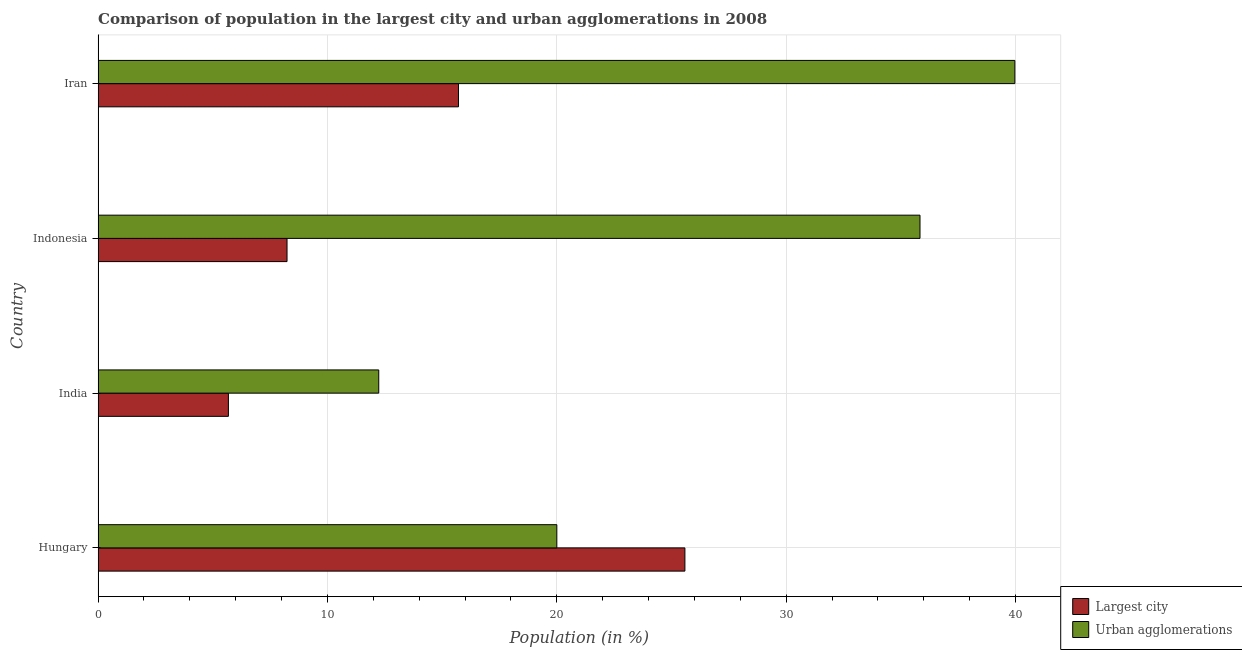How many different coloured bars are there?
Provide a succinct answer. 2. How many groups of bars are there?
Provide a succinct answer. 4. Are the number of bars on each tick of the Y-axis equal?
Give a very brief answer. Yes. How many bars are there on the 2nd tick from the top?
Provide a succinct answer. 2. How many bars are there on the 3rd tick from the bottom?
Make the answer very short. 2. What is the population in the largest city in Indonesia?
Offer a terse response. 8.24. Across all countries, what is the maximum population in the largest city?
Keep it short and to the point. 25.58. Across all countries, what is the minimum population in urban agglomerations?
Offer a very short reply. 12.24. In which country was the population in the largest city maximum?
Your response must be concise. Hungary. In which country was the population in urban agglomerations minimum?
Keep it short and to the point. India. What is the total population in urban agglomerations in the graph?
Make the answer very short. 108.04. What is the difference between the population in the largest city in India and that in Iran?
Your response must be concise. -10.03. What is the difference between the population in urban agglomerations in Hungary and the population in the largest city in Indonesia?
Provide a succinct answer. 11.76. What is the average population in the largest city per country?
Make the answer very short. 13.8. What is the difference between the population in urban agglomerations and population in the largest city in India?
Your answer should be very brief. 6.55. In how many countries, is the population in urban agglomerations greater than 26 %?
Ensure brevity in your answer.  2. What is the ratio of the population in urban agglomerations in Indonesia to that in Iran?
Keep it short and to the point. 0.9. Is the difference between the population in urban agglomerations in India and Indonesia greater than the difference between the population in the largest city in India and Indonesia?
Your answer should be compact. No. What is the difference between the highest and the second highest population in urban agglomerations?
Offer a very short reply. 4.14. What is the difference between the highest and the lowest population in urban agglomerations?
Provide a short and direct response. 27.73. Is the sum of the population in the largest city in India and Iran greater than the maximum population in urban agglomerations across all countries?
Provide a succinct answer. No. What does the 2nd bar from the top in India represents?
Provide a succinct answer. Largest city. What does the 2nd bar from the bottom in Hungary represents?
Give a very brief answer. Urban agglomerations. How many bars are there?
Keep it short and to the point. 8. How many countries are there in the graph?
Make the answer very short. 4. Does the graph contain any zero values?
Your response must be concise. No. How are the legend labels stacked?
Provide a succinct answer. Vertical. What is the title of the graph?
Offer a very short reply. Comparison of population in the largest city and urban agglomerations in 2008. What is the label or title of the Y-axis?
Provide a succinct answer. Country. What is the Population (in %) of Largest city in Hungary?
Give a very brief answer. 25.58. What is the Population (in %) in Urban agglomerations in Hungary?
Your response must be concise. 20. What is the Population (in %) in Largest city in India?
Keep it short and to the point. 5.68. What is the Population (in %) in Urban agglomerations in India?
Offer a very short reply. 12.24. What is the Population (in %) of Largest city in Indonesia?
Your answer should be very brief. 8.24. What is the Population (in %) of Urban agglomerations in Indonesia?
Give a very brief answer. 35.83. What is the Population (in %) of Largest city in Iran?
Your response must be concise. 15.71. What is the Population (in %) of Urban agglomerations in Iran?
Your answer should be compact. 39.97. Across all countries, what is the maximum Population (in %) in Largest city?
Ensure brevity in your answer.  25.58. Across all countries, what is the maximum Population (in %) of Urban agglomerations?
Keep it short and to the point. 39.97. Across all countries, what is the minimum Population (in %) in Largest city?
Your response must be concise. 5.68. Across all countries, what is the minimum Population (in %) of Urban agglomerations?
Give a very brief answer. 12.24. What is the total Population (in %) in Largest city in the graph?
Your answer should be compact. 55.21. What is the total Population (in %) in Urban agglomerations in the graph?
Give a very brief answer. 108.04. What is the difference between the Population (in %) of Largest city in Hungary and that in India?
Offer a terse response. 19.9. What is the difference between the Population (in %) of Urban agglomerations in Hungary and that in India?
Offer a terse response. 7.76. What is the difference between the Population (in %) of Largest city in Hungary and that in Indonesia?
Provide a short and direct response. 17.35. What is the difference between the Population (in %) in Urban agglomerations in Hungary and that in Indonesia?
Offer a terse response. -15.83. What is the difference between the Population (in %) in Largest city in Hungary and that in Iran?
Offer a very short reply. 9.87. What is the difference between the Population (in %) in Urban agglomerations in Hungary and that in Iran?
Ensure brevity in your answer.  -19.97. What is the difference between the Population (in %) of Largest city in India and that in Indonesia?
Your response must be concise. -2.56. What is the difference between the Population (in %) of Urban agglomerations in India and that in Indonesia?
Keep it short and to the point. -23.6. What is the difference between the Population (in %) in Largest city in India and that in Iran?
Provide a short and direct response. -10.03. What is the difference between the Population (in %) of Urban agglomerations in India and that in Iran?
Offer a terse response. -27.73. What is the difference between the Population (in %) in Largest city in Indonesia and that in Iran?
Ensure brevity in your answer.  -7.48. What is the difference between the Population (in %) in Urban agglomerations in Indonesia and that in Iran?
Ensure brevity in your answer.  -4.14. What is the difference between the Population (in %) of Largest city in Hungary and the Population (in %) of Urban agglomerations in India?
Provide a succinct answer. 13.35. What is the difference between the Population (in %) of Largest city in Hungary and the Population (in %) of Urban agglomerations in Indonesia?
Provide a succinct answer. -10.25. What is the difference between the Population (in %) of Largest city in Hungary and the Population (in %) of Urban agglomerations in Iran?
Make the answer very short. -14.39. What is the difference between the Population (in %) of Largest city in India and the Population (in %) of Urban agglomerations in Indonesia?
Your response must be concise. -30.15. What is the difference between the Population (in %) in Largest city in India and the Population (in %) in Urban agglomerations in Iran?
Provide a succinct answer. -34.29. What is the difference between the Population (in %) of Largest city in Indonesia and the Population (in %) of Urban agglomerations in Iran?
Offer a terse response. -31.73. What is the average Population (in %) of Largest city per country?
Give a very brief answer. 13.8. What is the average Population (in %) in Urban agglomerations per country?
Provide a succinct answer. 27.01. What is the difference between the Population (in %) in Largest city and Population (in %) in Urban agglomerations in Hungary?
Your response must be concise. 5.58. What is the difference between the Population (in %) of Largest city and Population (in %) of Urban agglomerations in India?
Your answer should be compact. -6.56. What is the difference between the Population (in %) in Largest city and Population (in %) in Urban agglomerations in Indonesia?
Make the answer very short. -27.6. What is the difference between the Population (in %) in Largest city and Population (in %) in Urban agglomerations in Iran?
Provide a succinct answer. -24.26. What is the ratio of the Population (in %) of Largest city in Hungary to that in India?
Give a very brief answer. 4.5. What is the ratio of the Population (in %) in Urban agglomerations in Hungary to that in India?
Provide a short and direct response. 1.63. What is the ratio of the Population (in %) of Largest city in Hungary to that in Indonesia?
Your response must be concise. 3.11. What is the ratio of the Population (in %) of Urban agglomerations in Hungary to that in Indonesia?
Give a very brief answer. 0.56. What is the ratio of the Population (in %) in Largest city in Hungary to that in Iran?
Give a very brief answer. 1.63. What is the ratio of the Population (in %) of Urban agglomerations in Hungary to that in Iran?
Ensure brevity in your answer.  0.5. What is the ratio of the Population (in %) of Largest city in India to that in Indonesia?
Your response must be concise. 0.69. What is the ratio of the Population (in %) of Urban agglomerations in India to that in Indonesia?
Offer a very short reply. 0.34. What is the ratio of the Population (in %) of Largest city in India to that in Iran?
Your answer should be compact. 0.36. What is the ratio of the Population (in %) in Urban agglomerations in India to that in Iran?
Keep it short and to the point. 0.31. What is the ratio of the Population (in %) in Largest city in Indonesia to that in Iran?
Provide a short and direct response. 0.52. What is the ratio of the Population (in %) of Urban agglomerations in Indonesia to that in Iran?
Provide a short and direct response. 0.9. What is the difference between the highest and the second highest Population (in %) of Largest city?
Offer a terse response. 9.87. What is the difference between the highest and the second highest Population (in %) in Urban agglomerations?
Offer a terse response. 4.14. What is the difference between the highest and the lowest Population (in %) in Largest city?
Give a very brief answer. 19.9. What is the difference between the highest and the lowest Population (in %) of Urban agglomerations?
Give a very brief answer. 27.73. 